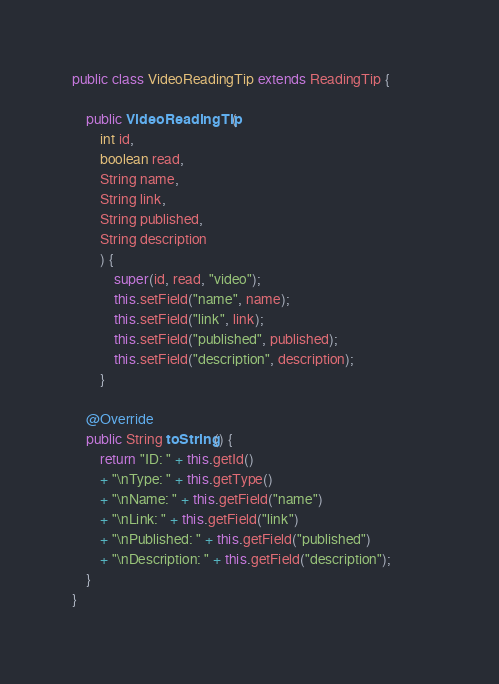Convert code to text. <code><loc_0><loc_0><loc_500><loc_500><_Java_>public class VideoReadingTip extends ReadingTip {
    
    public VideoReadingTip(
        int id,
        boolean read,
        String name,
        String link,
        String published,
        String description
        ) {
            super(id, read, "video");
            this.setField("name", name);
            this.setField("link", link);
            this.setField("published", published);
            this.setField("description", description);
        }

    @Override
    public String toString() {
        return "ID: " + this.getId()
        + "\nType: " + this.getType()
        + "\nName: " + this.getField("name")
        + "\nLink: " + this.getField("link")
        + "\nPublished: " + this.getField("published")                
        + "\nDescription: " + this.getField("description");
    }
}
</code> 